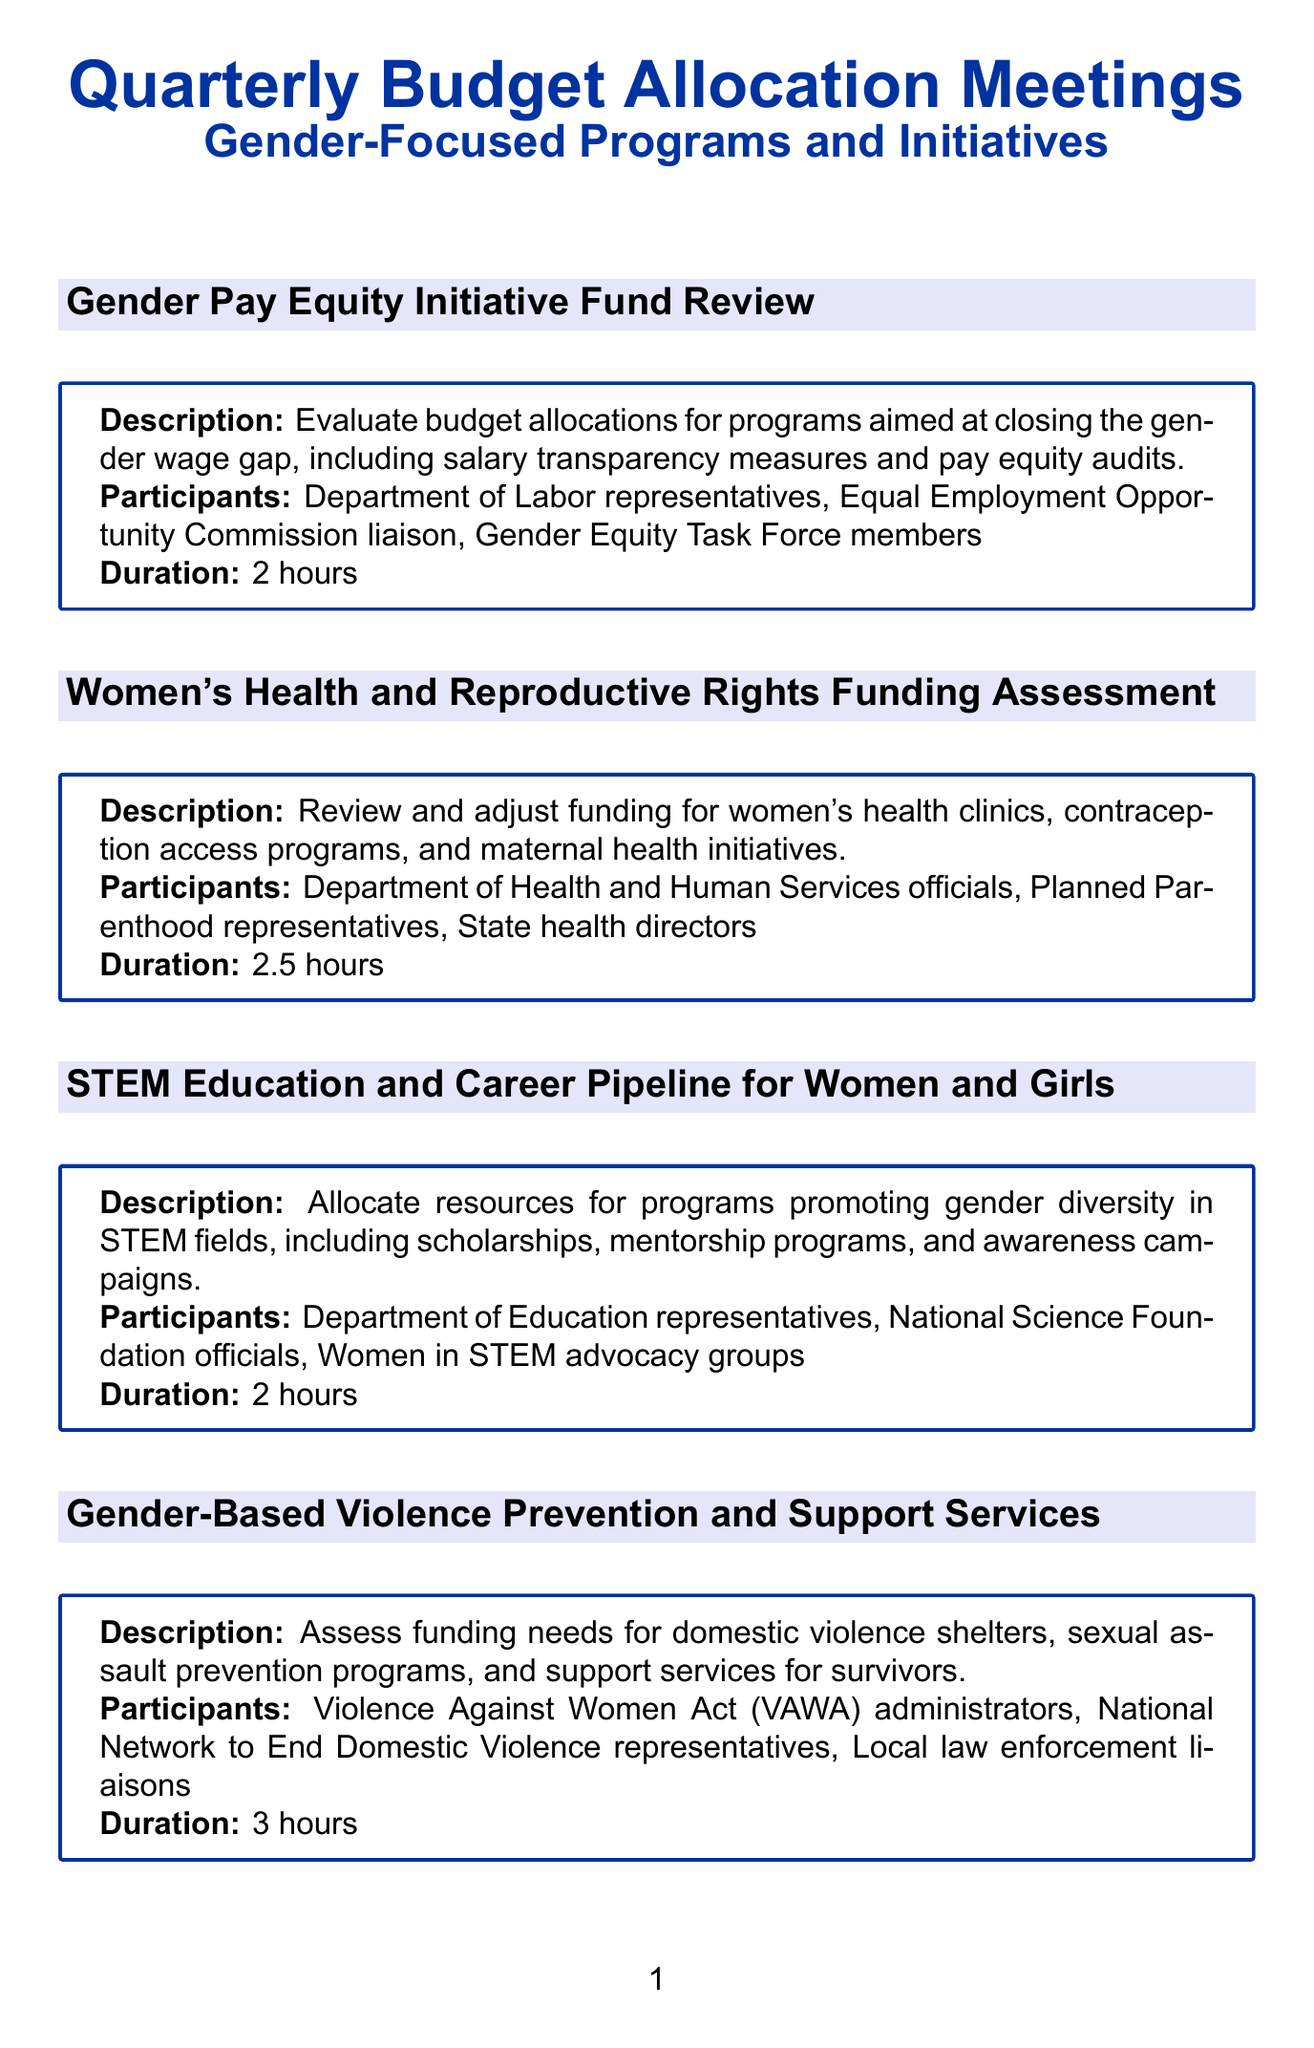What is the duration of the "Gender-Based Violence Prevention and Support Services" meeting? The duration of each meeting is stated in the document, and for this meeting, it is 3 hours.
Answer: 3 hours Who are the participants in the "Women's Health and Reproductive Rights Funding Assessment" meeting? The meeting participants are listed, and they include Department of Health and Human Services officials, Planned Parenthood representatives, and State health directors.
Answer: Department of Health and Human Services officials, Planned Parenthood representatives, State health directors Which initiative focuses on gender diversity in STEM fields? The document provides titles for each meeting, and this one specifically mentions gender diversity in STEM fields.
Answer: STEM Education and Career Pipeline for Women and Girls What is the focus of the "Childcare and Early Education Accessibility" meeting? The focus for each meeting is described, and this one is about universal pre-K initiatives, childcare subsidies, and policies supporting working parents.
Answer: Universal pre-K initiatives, childcare subsidies, policies supporting working parents How many meetings have a duration of 2.5 hours? To answer this, we can count the meetings listed that have this duration stated next to them in the document.
Answer: 3 